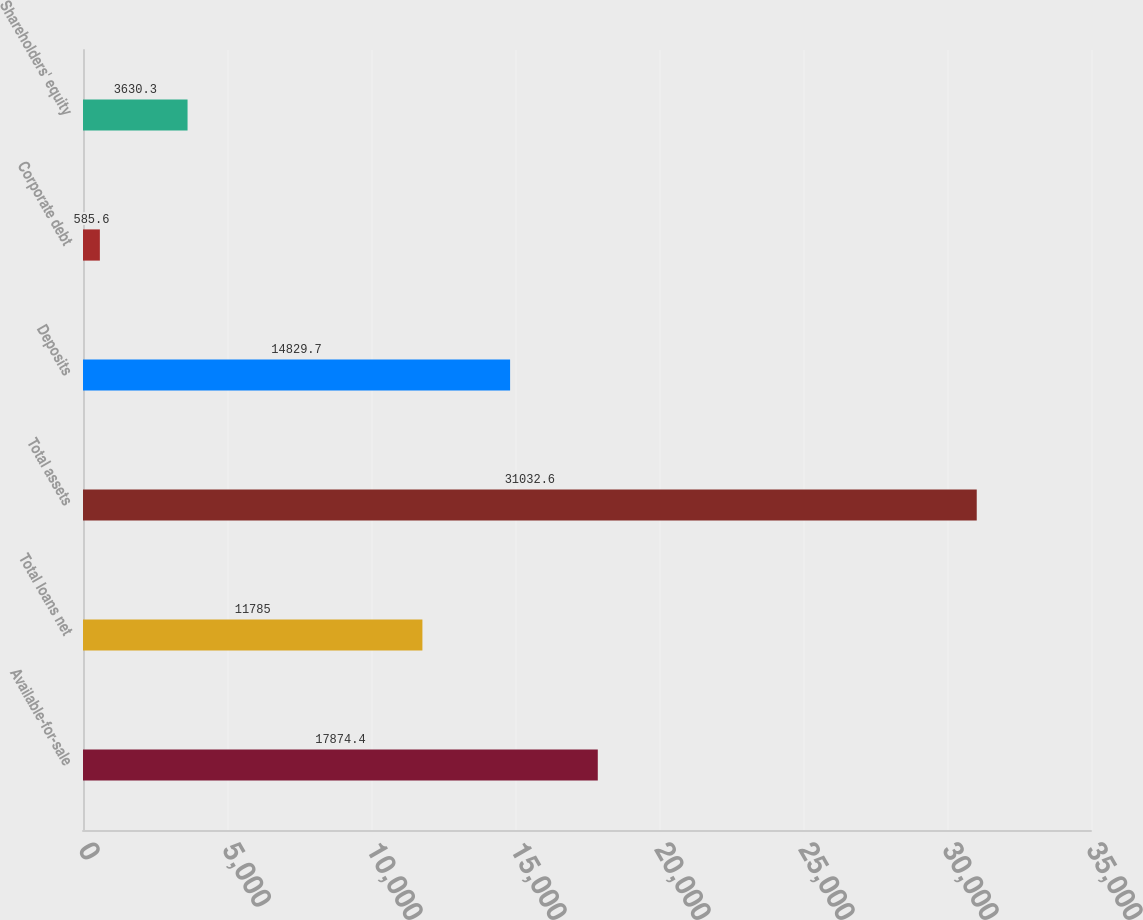Convert chart to OTSL. <chart><loc_0><loc_0><loc_500><loc_500><bar_chart><fcel>Available-for-sale<fcel>Total loans net<fcel>Total assets<fcel>Deposits<fcel>Corporate debt<fcel>Shareholders' equity<nl><fcel>17874.4<fcel>11785<fcel>31032.6<fcel>14829.7<fcel>585.6<fcel>3630.3<nl></chart> 